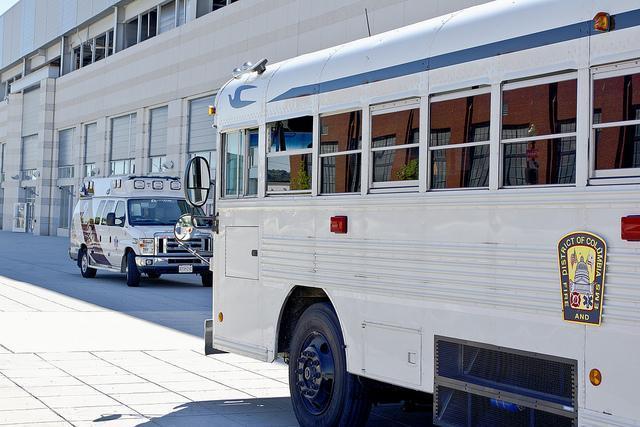Is the statement "The bus is behind the truck." accurate regarding the image?
Answer yes or no. No. 